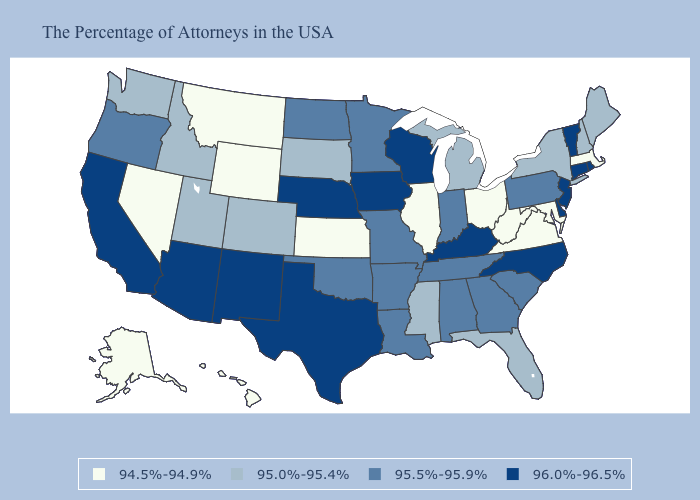Does Missouri have the lowest value in the MidWest?
Write a very short answer. No. Name the states that have a value in the range 96.0%-96.5%?
Write a very short answer. Rhode Island, Vermont, Connecticut, New Jersey, Delaware, North Carolina, Kentucky, Wisconsin, Iowa, Nebraska, Texas, New Mexico, Arizona, California. Name the states that have a value in the range 95.0%-95.4%?
Concise answer only. Maine, New Hampshire, New York, Florida, Michigan, Mississippi, South Dakota, Colorado, Utah, Idaho, Washington. Does Connecticut have a higher value than New York?
Concise answer only. Yes. Is the legend a continuous bar?
Concise answer only. No. What is the highest value in the USA?
Short answer required. 96.0%-96.5%. What is the highest value in the USA?
Give a very brief answer. 96.0%-96.5%. What is the value of Kentucky?
Keep it brief. 96.0%-96.5%. Which states have the highest value in the USA?
Keep it brief. Rhode Island, Vermont, Connecticut, New Jersey, Delaware, North Carolina, Kentucky, Wisconsin, Iowa, Nebraska, Texas, New Mexico, Arizona, California. What is the value of Iowa?
Keep it brief. 96.0%-96.5%. Among the states that border Colorado , does New Mexico have the highest value?
Quick response, please. Yes. Among the states that border West Virginia , which have the highest value?
Quick response, please. Kentucky. What is the highest value in the West ?
Keep it brief. 96.0%-96.5%. Among the states that border Kansas , does Colorado have the lowest value?
Keep it brief. Yes. 